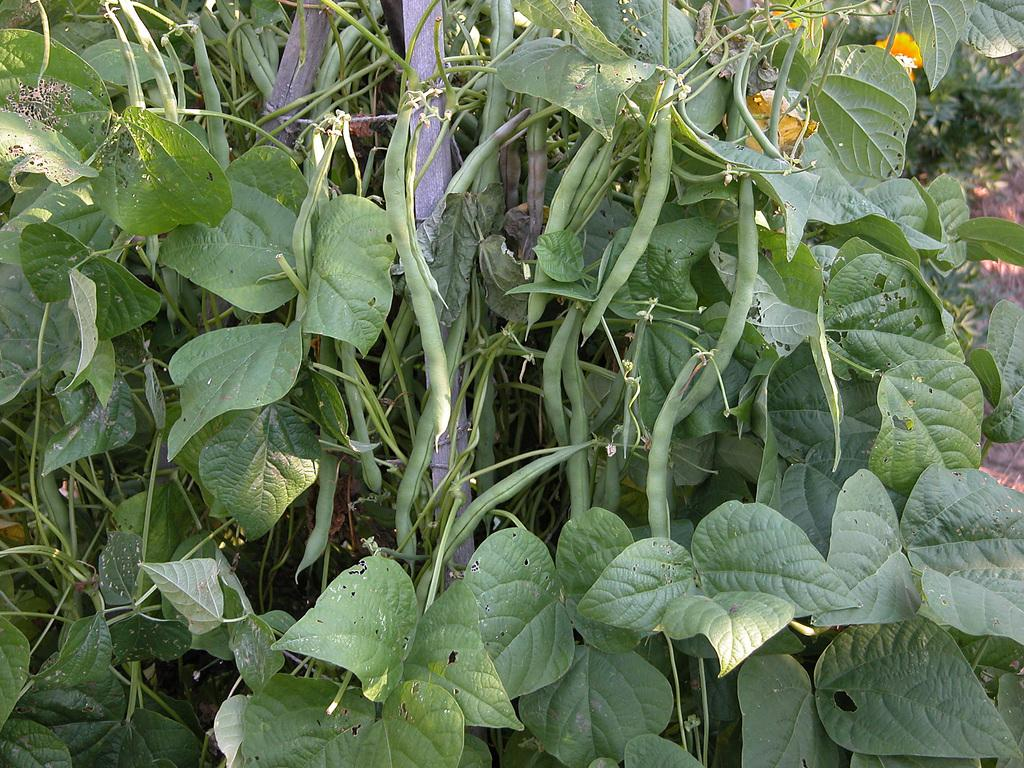What objects can be seen in the image? There are wooden sticks and creeper plants with beans and leaves in the image. Can you describe the creeper plants in more detail? The creeper plants have beans and leaves on the front side of the image. What else is visible in the image? There are plants on the land in the right top part of the image. What songs are being sung by the birds in the nest in the image? There is no nest or birds present in the image, so no songs can be heard. 